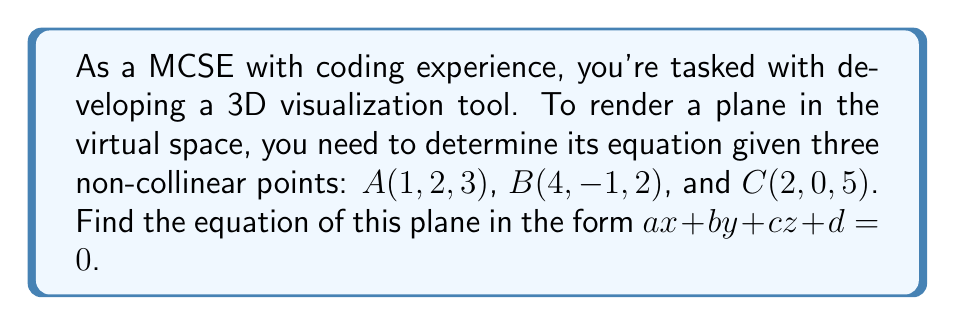What is the answer to this math problem? 1. To find the equation of a plane given three non-collinear points, we can follow these steps:

   a. Calculate two vectors on the plane
   b. Find the normal vector to the plane using cross product
   c. Use the normal vector and a point to determine the equation

2. Let's calculate two vectors on the plane:
   $\vec{AB} = B - A = (4-1, -1-2, 2-3) = (3, -3, -1)$
   $\vec{AC} = C - A = (2-1, 0-2, 5-3) = (1, -2, 2)$

3. Find the normal vector $\vec{n}$ using cross product:
   $$\vec{n} = \vec{AB} \times \vec{AC} = \begin{vmatrix} 
   i & j & k \\
   3 & -3 & -1 \\
   1 & -2 & 2
   \end{vmatrix}$$

   $\vec{n} = ((-3)(2) - (-1)(-2))i - ((3)(2) - (-1)(1))j + ((3)(-2) - (-3)(1))k$
   $\vec{n} = (-6 - 2)i - (6 + 1)j + (-6 - 3)k$
   $\vec{n} = -8i - 7j - 9k$

4. The normal vector gives us the coefficients $a$, $b$, and $c$:
   $a = -8$, $b = -7$, $c = -9$

5. Use point $A(1, 2, 3)$ to find $d$:
   $-8(1) + -7(2) + -9(3) + d = 0$
   $-8 - 14 - 27 + d = 0$
   $d = 49$

6. Therefore, the equation of the plane is:
   $-8x - 7y - 9z + 49 = 0$
Answer: $-8x - 7y - 9z + 49 = 0$ 